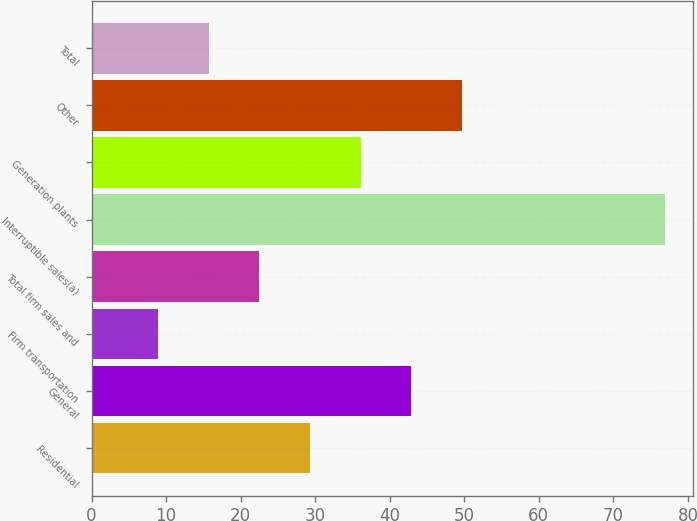<chart> <loc_0><loc_0><loc_500><loc_500><bar_chart><fcel>Residential<fcel>General<fcel>Firm transportation<fcel>Total firm sales and<fcel>Interruptible sales(a)<fcel>Generation plants<fcel>Other<fcel>Total<nl><fcel>29.3<fcel>42.9<fcel>8.9<fcel>22.5<fcel>76.9<fcel>36.1<fcel>49.7<fcel>15.7<nl></chart> 